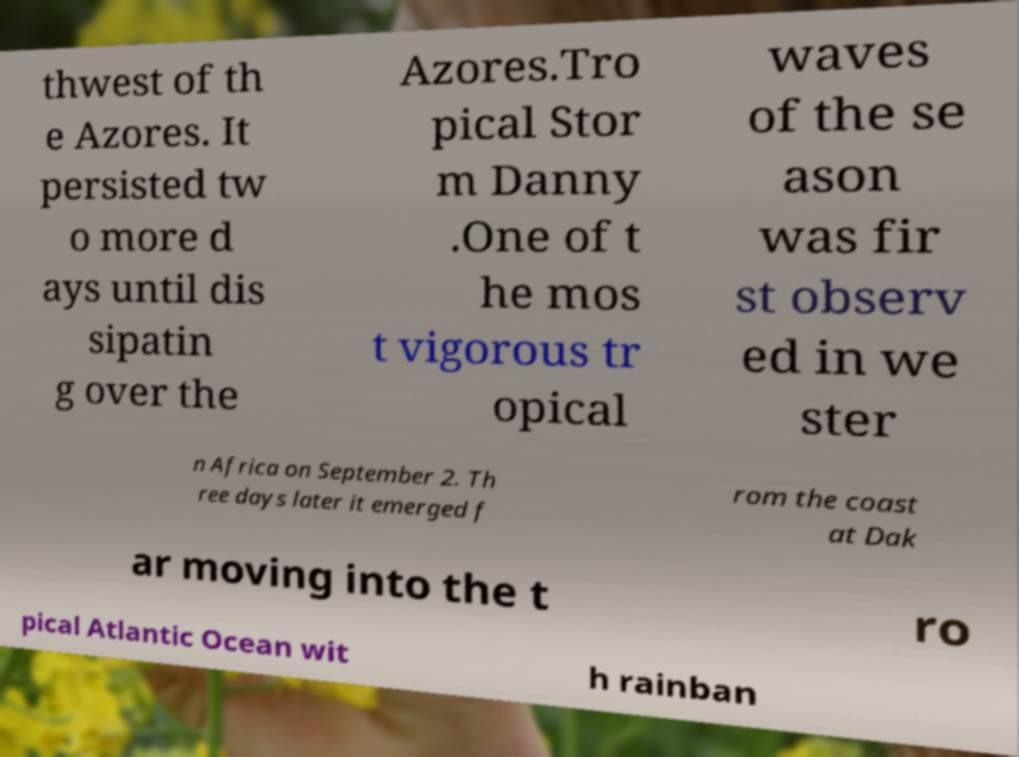Please identify and transcribe the text found in this image. thwest of th e Azores. It persisted tw o more d ays until dis sipatin g over the Azores.Tro pical Stor m Danny .One of t he mos t vigorous tr opical waves of the se ason was fir st observ ed in we ster n Africa on September 2. Th ree days later it emerged f rom the coast at Dak ar moving into the t ro pical Atlantic Ocean wit h rainban 